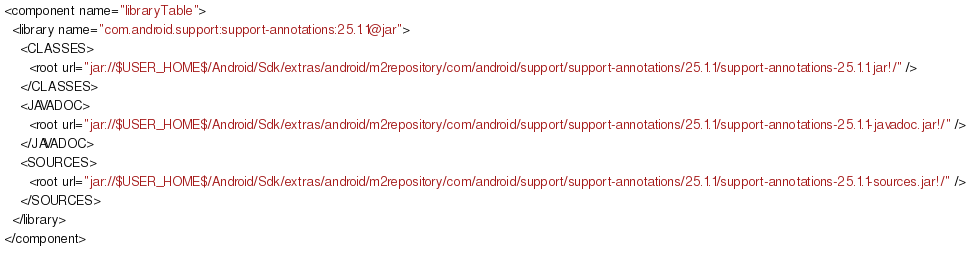Convert code to text. <code><loc_0><loc_0><loc_500><loc_500><_XML_><component name="libraryTable">
  <library name="com.android.support:support-annotations:25.1.1@jar">
    <CLASSES>
      <root url="jar://$USER_HOME$/Android/Sdk/extras/android/m2repository/com/android/support/support-annotations/25.1.1/support-annotations-25.1.1.jar!/" />
    </CLASSES>
    <JAVADOC>
      <root url="jar://$USER_HOME$/Android/Sdk/extras/android/m2repository/com/android/support/support-annotations/25.1.1/support-annotations-25.1.1-javadoc.jar!/" />
    </JAVADOC>
    <SOURCES>
      <root url="jar://$USER_HOME$/Android/Sdk/extras/android/m2repository/com/android/support/support-annotations/25.1.1/support-annotations-25.1.1-sources.jar!/" />
    </SOURCES>
  </library>
</component></code> 